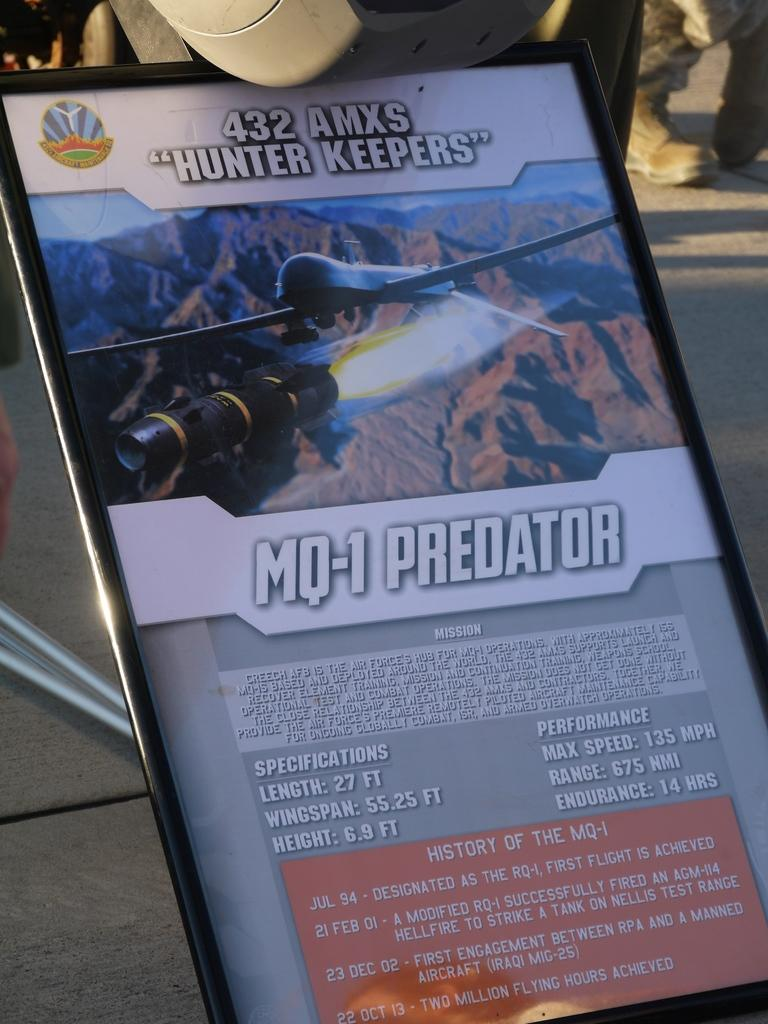<image>
Present a compact description of the photo's key features. a poster item that has mq-1 predator on it 